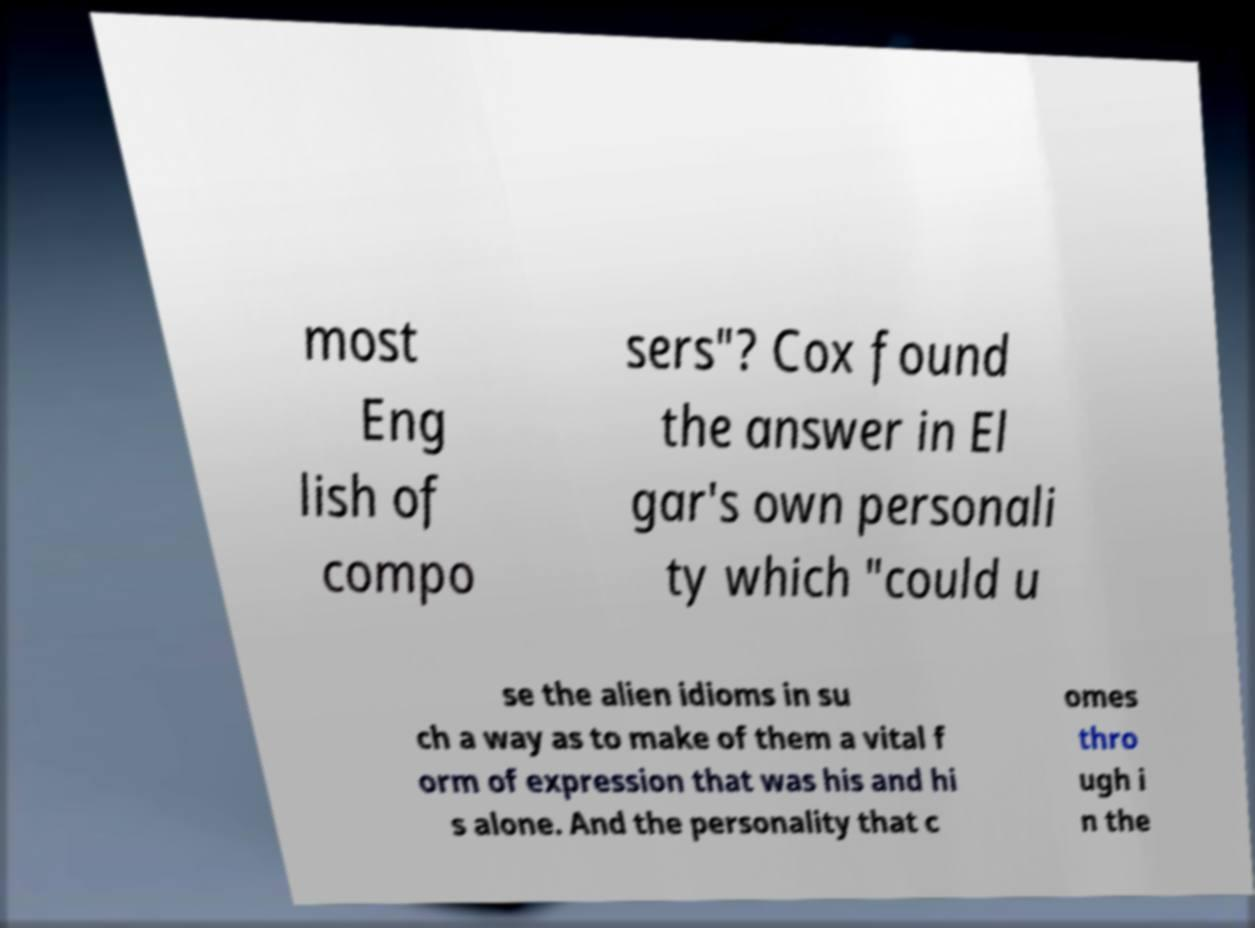There's text embedded in this image that I need extracted. Can you transcribe it verbatim? most Eng lish of compo sers"? Cox found the answer in El gar's own personali ty which "could u se the alien idioms in su ch a way as to make of them a vital f orm of expression that was his and hi s alone. And the personality that c omes thro ugh i n the 